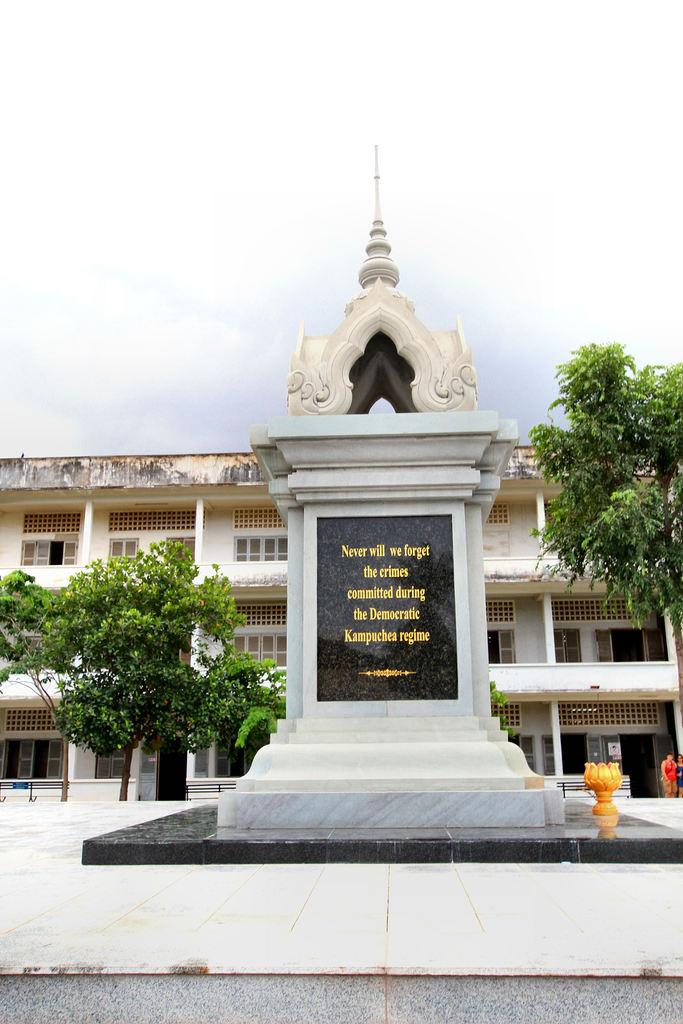<image>
Give a short and clear explanation of the subsequent image. A sculpture reads never will we forget the crimes committed during the Democratic Kampuchea regime. 